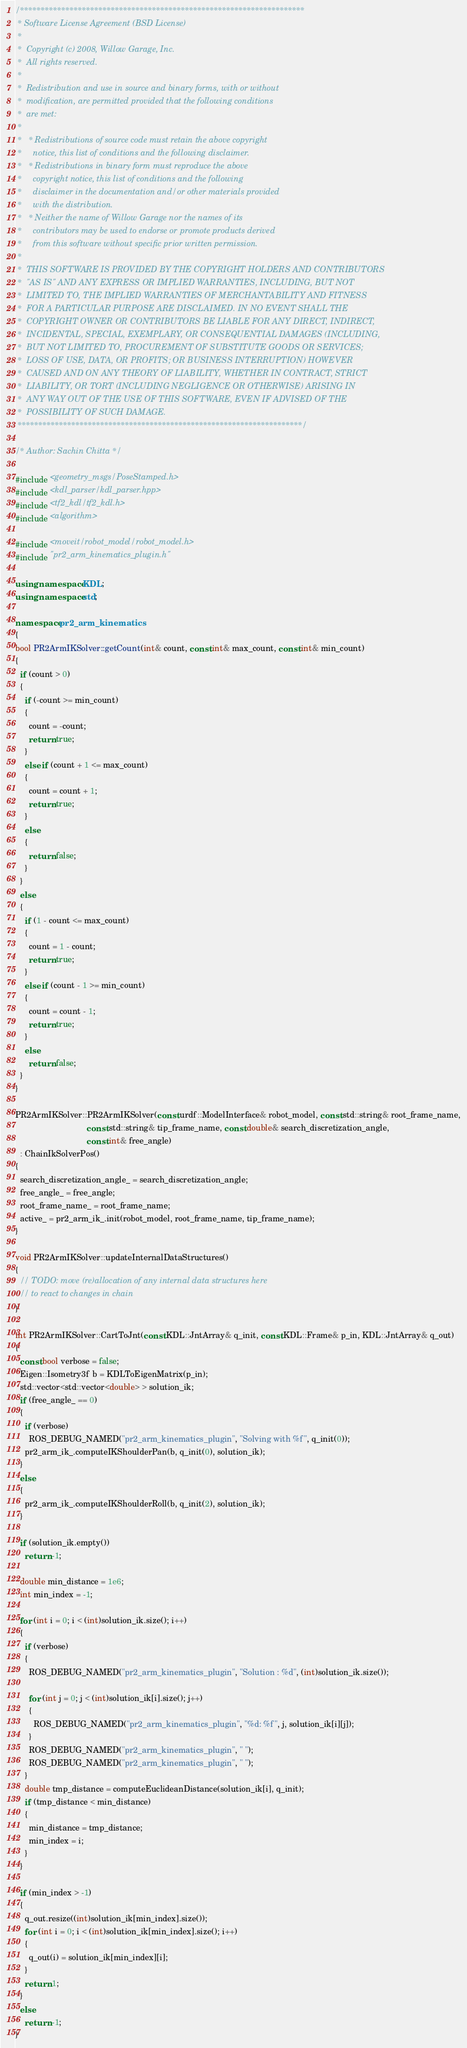Convert code to text. <code><loc_0><loc_0><loc_500><loc_500><_C++_>/*********************************************************************
 * Software License Agreement (BSD License)
 *
 *  Copyright (c) 2008, Willow Garage, Inc.
 *  All rights reserved.
 *
 *  Redistribution and use in source and binary forms, with or without
 *  modification, are permitted provided that the following conditions
 *  are met:
 *
 *   * Redistributions of source code must retain the above copyright
 *     notice, this list of conditions and the following disclaimer.
 *   * Redistributions in binary form must reproduce the above
 *     copyright notice, this list of conditions and the following
 *     disclaimer in the documentation and/or other materials provided
 *     with the distribution.
 *   * Neither the name of Willow Garage nor the names of its
 *     contributors may be used to endorse or promote products derived
 *     from this software without specific prior written permission.
 *
 *  THIS SOFTWARE IS PROVIDED BY THE COPYRIGHT HOLDERS AND CONTRIBUTORS
 *  "AS IS" AND ANY EXPRESS OR IMPLIED WARRANTIES, INCLUDING, BUT NOT
 *  LIMITED TO, THE IMPLIED WARRANTIES OF MERCHANTABILITY AND FITNESS
 *  FOR A PARTICULAR PURPOSE ARE DISCLAIMED. IN NO EVENT SHALL THE
 *  COPYRIGHT OWNER OR CONTRIBUTORS BE LIABLE FOR ANY DIRECT, INDIRECT,
 *  INCIDENTAL, SPECIAL, EXEMPLARY, OR CONSEQUENTIAL DAMAGES (INCLUDING,
 *  BUT NOT LIMITED TO, PROCUREMENT OF SUBSTITUTE GOODS OR SERVICES;
 *  LOSS OF USE, DATA, OR PROFITS; OR BUSINESS INTERRUPTION) HOWEVER
 *  CAUSED AND ON ANY THEORY OF LIABILITY, WHETHER IN CONTRACT, STRICT
 *  LIABILITY, OR TORT (INCLUDING NEGLIGENCE OR OTHERWISE) ARISING IN
 *  ANY WAY OUT OF THE USE OF THIS SOFTWARE, EVEN IF ADVISED OF THE
 *  POSSIBILITY OF SUCH DAMAGE.
 *********************************************************************/

/* Author: Sachin Chitta */

#include <geometry_msgs/PoseStamped.h>
#include <kdl_parser/kdl_parser.hpp>
#include <tf2_kdl/tf2_kdl.h>
#include <algorithm>

#include <moveit/robot_model/robot_model.h>
#include "pr2_arm_kinematics_plugin.h"

using namespace KDL;
using namespace std;

namespace pr2_arm_kinematics
{
bool PR2ArmIKSolver::getCount(int& count, const int& max_count, const int& min_count)
{
  if (count > 0)
  {
    if (-count >= min_count)
    {
      count = -count;
      return true;
    }
    else if (count + 1 <= max_count)
    {
      count = count + 1;
      return true;
    }
    else
    {
      return false;
    }
  }
  else
  {
    if (1 - count <= max_count)
    {
      count = 1 - count;
      return true;
    }
    else if (count - 1 >= min_count)
    {
      count = count - 1;
      return true;
    }
    else
      return false;
  }
}

PR2ArmIKSolver::PR2ArmIKSolver(const urdf::ModelInterface& robot_model, const std::string& root_frame_name,
                               const std::string& tip_frame_name, const double& search_discretization_angle,
                               const int& free_angle)
  : ChainIkSolverPos()
{
  search_discretization_angle_ = search_discretization_angle;
  free_angle_ = free_angle;
  root_frame_name_ = root_frame_name;
  active_ = pr2_arm_ik_.init(robot_model, root_frame_name, tip_frame_name);
}

void PR2ArmIKSolver::updateInternalDataStructures()
{
  // TODO: move (re)allocation of any internal data structures here
  // to react to changes in chain
}

int PR2ArmIKSolver::CartToJnt(const KDL::JntArray& q_init, const KDL::Frame& p_in, KDL::JntArray& q_out)
{
  const bool verbose = false;
  Eigen::Isometry3f b = KDLToEigenMatrix(p_in);
  std::vector<std::vector<double> > solution_ik;
  if (free_angle_ == 0)
  {
    if (verbose)
      ROS_DEBUG_NAMED("pr2_arm_kinematics_plugin", "Solving with %f", q_init(0));
    pr2_arm_ik_.computeIKShoulderPan(b, q_init(0), solution_ik);
  }
  else
  {
    pr2_arm_ik_.computeIKShoulderRoll(b, q_init(2), solution_ik);
  }

  if (solution_ik.empty())
    return -1;

  double min_distance = 1e6;
  int min_index = -1;

  for (int i = 0; i < (int)solution_ik.size(); i++)
  {
    if (verbose)
    {
      ROS_DEBUG_NAMED("pr2_arm_kinematics_plugin", "Solution : %d", (int)solution_ik.size());

      for (int j = 0; j < (int)solution_ik[i].size(); j++)
      {
        ROS_DEBUG_NAMED("pr2_arm_kinematics_plugin", "%d: %f", j, solution_ik[i][j]);
      }
      ROS_DEBUG_NAMED("pr2_arm_kinematics_plugin", " ");
      ROS_DEBUG_NAMED("pr2_arm_kinematics_plugin", " ");
    }
    double tmp_distance = computeEuclideanDistance(solution_ik[i], q_init);
    if (tmp_distance < min_distance)
    {
      min_distance = tmp_distance;
      min_index = i;
    }
  }

  if (min_index > -1)
  {
    q_out.resize((int)solution_ik[min_index].size());
    for (int i = 0; i < (int)solution_ik[min_index].size(); i++)
    {
      q_out(i) = solution_ik[min_index][i];
    }
    return 1;
  }
  else
    return -1;
}
</code> 